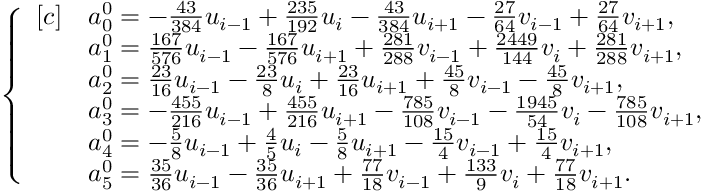Convert formula to latex. <formula><loc_0><loc_0><loc_500><loc_500>\begin{array} { r } { \left \{ \begin{array} { r l } { [ c ] } & { a _ { 0 } ^ { 0 } = - \frac { 4 3 } { 3 8 4 } u _ { i - 1 } + \frac { 2 3 5 } { 1 9 2 } u _ { i } - \frac { 4 3 } { 3 8 4 } u _ { i + 1 } - \frac { 2 7 } { 6 4 } v _ { i - 1 } + \frac { 2 7 } { 6 4 } v _ { i + 1 } , } \\ & { a _ { 1 } ^ { 0 } = \frac { 1 6 7 } { 5 7 6 } u _ { i - 1 } - \frac { 1 6 7 } { 5 7 6 } u _ { i + 1 } + \frac { 2 8 1 } { 2 8 8 } v _ { i - 1 } + \frac { 2 4 4 9 } { 1 4 4 } v _ { i } + \frac { 2 8 1 } { 2 8 8 } v _ { i + 1 } , } \\ & { a _ { 2 } ^ { 0 } = \frac { 2 3 } { 1 6 } u _ { i - 1 } - \frac { 2 3 } { 8 } u _ { i } + \frac { 2 3 } { 1 6 } u _ { i + 1 } + \frac { 4 5 } { 8 } v _ { i - 1 } - \frac { 4 5 } { 8 } v _ { i + 1 } , } \\ & { a _ { 3 } ^ { 0 } = - \frac { 4 5 5 } { 2 1 6 } u _ { i - 1 } + \frac { 4 5 5 } { 2 1 6 } u _ { i + 1 } - \frac { 7 8 5 } { 1 0 8 } v _ { i - 1 } - \frac { 1 9 4 5 } { 5 4 } v _ { i } - \frac { 7 8 5 } { 1 0 8 } v _ { i + 1 } , } \\ & { a _ { 4 } ^ { 0 } = - \frac { 5 } { 8 } u _ { i - 1 } + \frac { 4 } { 5 } u _ { i } - \frac { 5 } { 8 } u _ { i + 1 } - \frac { 1 5 } { 4 } v _ { i - 1 } + \frac { 1 5 } { 4 } v _ { i + 1 } , } \\ & { a _ { 5 } ^ { 0 } = \frac { 3 5 } { 3 6 } u _ { i - 1 } - \frac { 3 5 } { 3 6 } u _ { i + 1 } + \frac { 7 7 } { 1 8 } v _ { i - 1 } + \frac { 1 3 3 } { 9 } v _ { i } + \frac { 7 7 } { 1 8 } v _ { i + 1 } . } \end{array} } \end{array}</formula> 